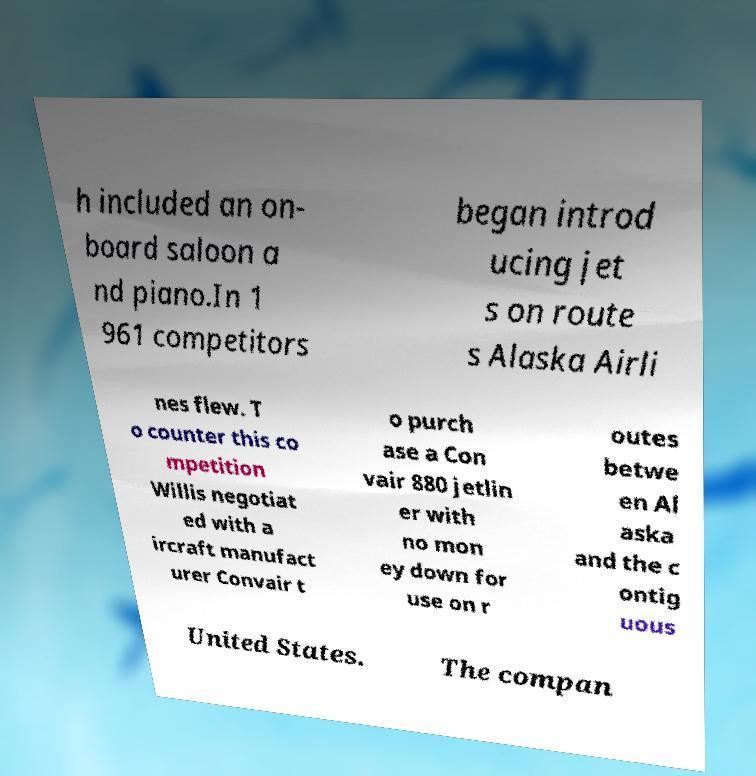Can you read and provide the text displayed in the image?This photo seems to have some interesting text. Can you extract and type it out for me? h included an on- board saloon a nd piano.In 1 961 competitors began introd ucing jet s on route s Alaska Airli nes flew. T o counter this co mpetition Willis negotiat ed with a ircraft manufact urer Convair t o purch ase a Con vair 880 jetlin er with no mon ey down for use on r outes betwe en Al aska and the c ontig uous United States. The compan 